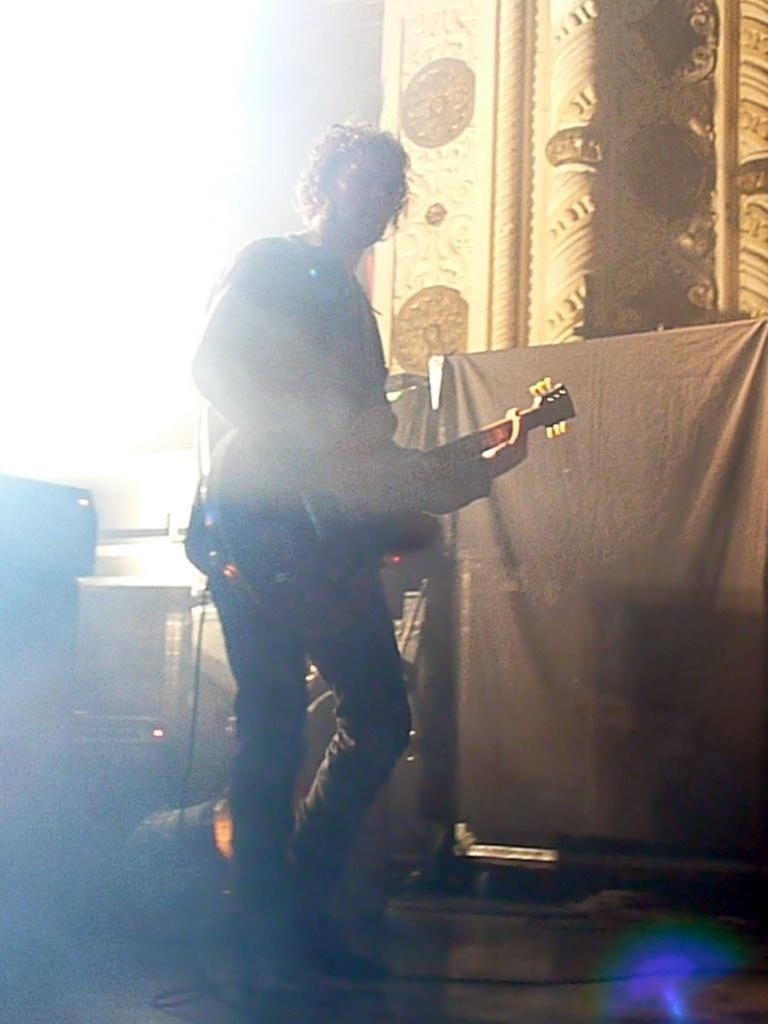What is the person in the image doing? The person is standing and playing a guitar. What other objects are related to music in the image? There are musical instruments behind the person. What color is the cloth in the right corner of the image? The cloth in the right corner of the image is black. How many snails can be seen crawling on the guitar in the image? There are no snails visible in the image; the person is playing a guitar without any snails present. 